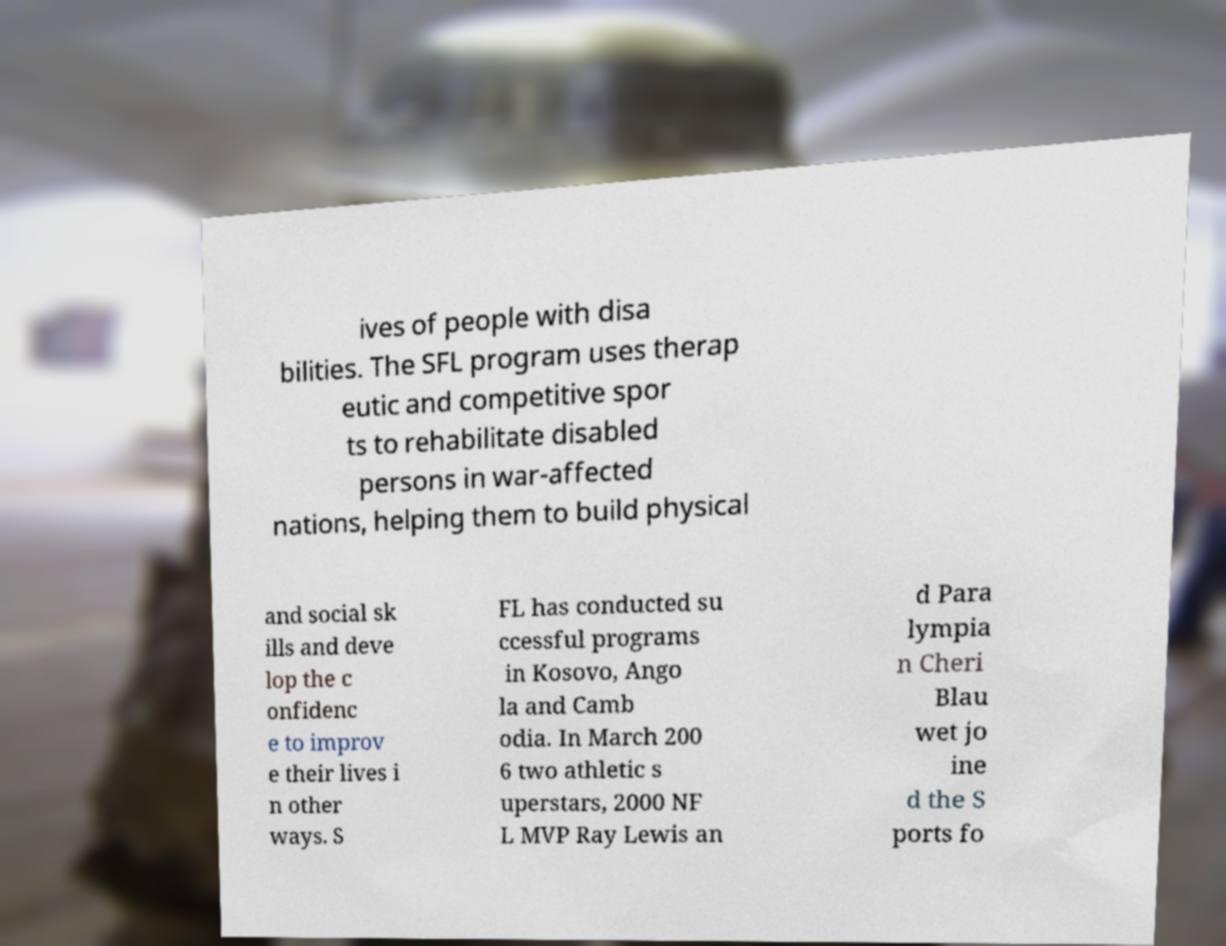Please identify and transcribe the text found in this image. ives of people with disa bilities. The SFL program uses therap eutic and competitive spor ts to rehabilitate disabled persons in war-affected nations, helping them to build physical and social sk ills and deve lop the c onfidenc e to improv e their lives i n other ways. S FL has conducted su ccessful programs in Kosovo, Ango la and Camb odia. In March 200 6 two athletic s uperstars, 2000 NF L MVP Ray Lewis an d Para lympia n Cheri Blau wet jo ine d the S ports fo 